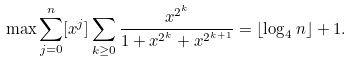<formula> <loc_0><loc_0><loc_500><loc_500>\max \sum _ { j = 0 } ^ { n } [ x ^ { j } ] \sum _ { k \geq 0 } \frac { x ^ { 2 ^ { k } } } { 1 + x ^ { 2 ^ { k } } + x ^ { 2 ^ { k + 1 } } } = \lfloor \log _ { 4 } n \rfloor + 1 .</formula> 